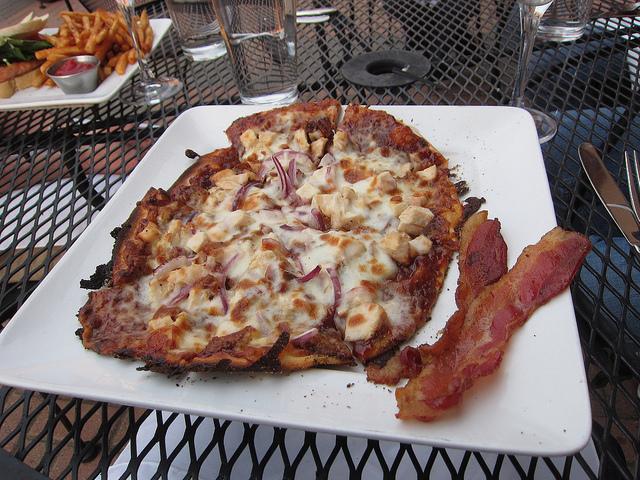How many pieces of bacon are next to the pizza?
Concise answer only. 2. What type of cheese is on the pizza?
Short answer required. Mozzarella. Is this meal good for you or loaded with fat and cholesterol?
Answer briefly. Loaded with fat and cholesterol. 